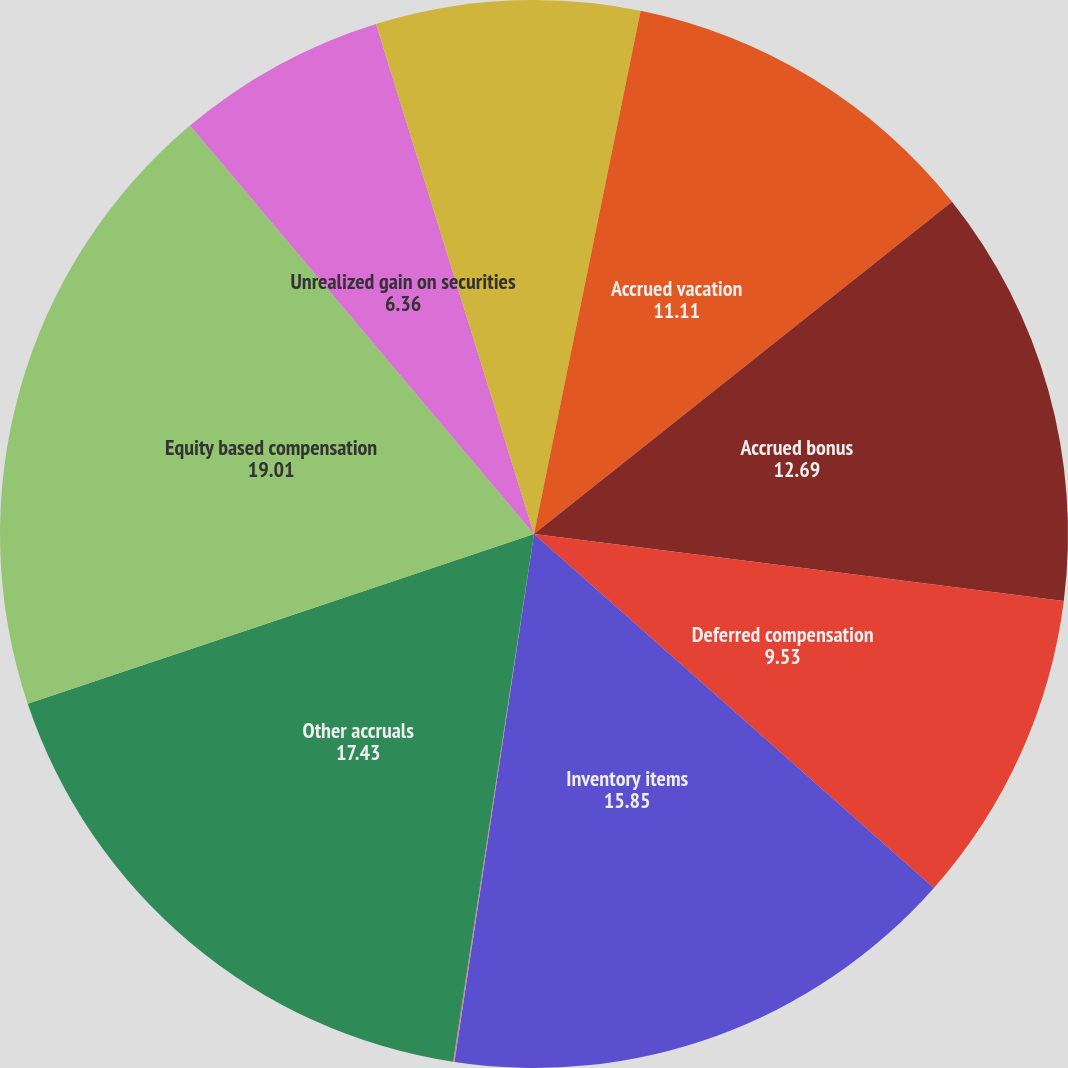<chart> <loc_0><loc_0><loc_500><loc_500><pie_chart><fcel>Deferred rent<fcel>Accrued vacation<fcel>Accrued bonus<fcel>Deferred compensation<fcel>Inventory items<fcel>Allowance for doubtful<fcel>Other accruals<fcel>Equity based compensation<fcel>Unrealized gain on securities<fcel>Unrealized loss on other<nl><fcel>3.2%<fcel>11.11%<fcel>12.69%<fcel>9.53%<fcel>15.85%<fcel>0.04%<fcel>17.43%<fcel>19.01%<fcel>6.36%<fcel>4.78%<nl></chart> 